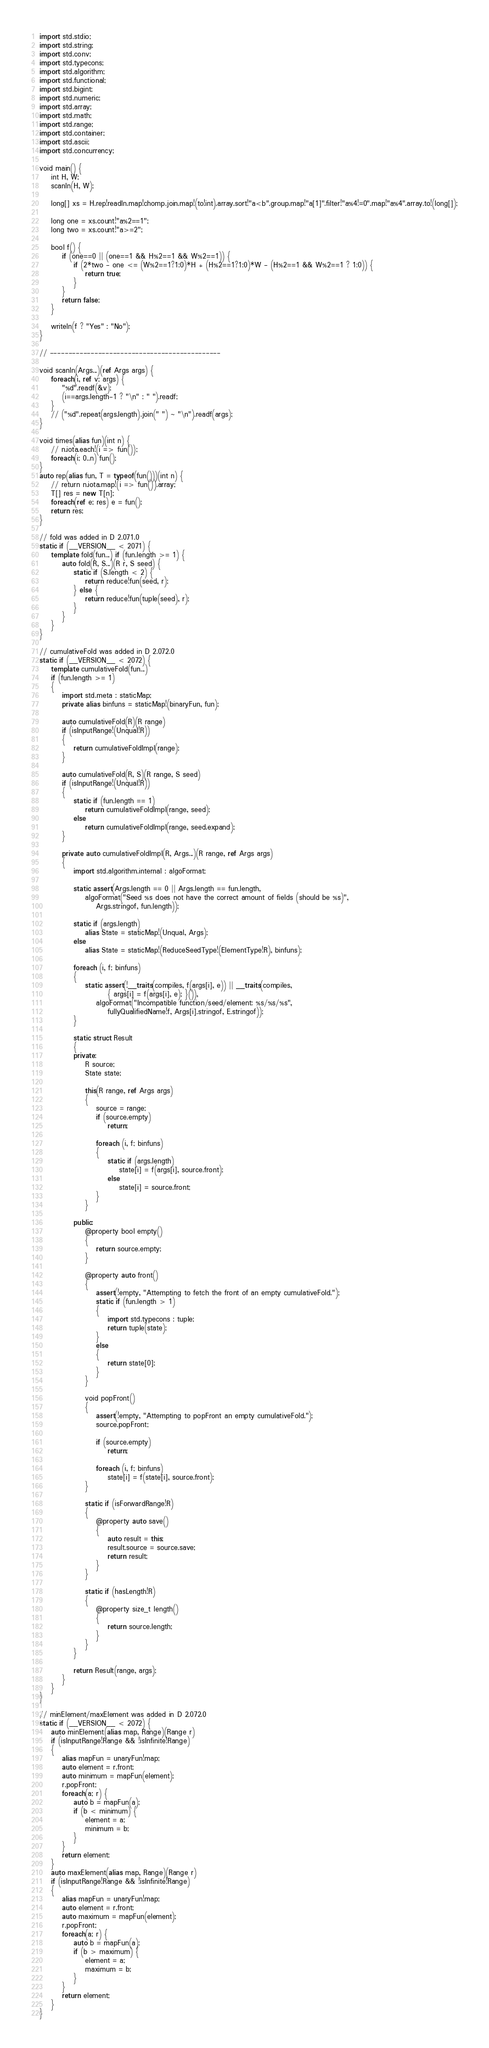Convert code to text. <code><loc_0><loc_0><loc_500><loc_500><_D_>import std.stdio;
import std.string;
import std.conv;
import std.typecons;
import std.algorithm;
import std.functional;
import std.bigint;
import std.numeric;
import std.array;
import std.math;
import std.range;
import std.container;
import std.ascii;
import std.concurrency;

void main() {
    int H, W;
    scanln(H, W);

    long[] xs = H.rep!readln.map!chomp.join.map!(to!int).array.sort!"a<b".group.map!"a[1]".filter!"a%4!=0".map!"a%4".array.to!(long[]);

    long one = xs.count!"a%2==1";
    long two = xs.count!"a>=2";

    bool f() {
        if (one==0 || (one==1 && H%2==1 && W%2==1)) {
            if (2*two - one <= (W%2==1?1:0)*H + (H%2==1?1:0)*W - (H%2==1 && W%2==1 ? 1:0)) {
                return true;
            }
        }
        return false;
    }

    writeln(f ? "Yes" : "No");
}

// ----------------------------------------------

void scanln(Args...)(ref Args args) {
    foreach(i, ref v; args) {
        "%d".readf(&v);
        (i==args.length-1 ? "\n" : " ").readf;
    }
    // ("%d".repeat(args.length).join(" ") ~ "\n").readf(args);
}

void times(alias fun)(int n) {
    // n.iota.each!(i => fun());
    foreach(i; 0..n) fun();
}
auto rep(alias fun, T = typeof(fun()))(int n) {
    // return n.iota.map!(i => fun()).array;
    T[] res = new T[n];
    foreach(ref e; res) e = fun();
    return res;
}

// fold was added in D 2.071.0
static if (__VERSION__ < 2071) {
    template fold(fun...) if (fun.length >= 1) {
        auto fold(R, S...)(R r, S seed) {
            static if (S.length < 2) {
                return reduce!fun(seed, r);
            } else {
                return reduce!fun(tuple(seed), r);
            }
        }
    }
}

// cumulativeFold was added in D 2.072.0
static if (__VERSION__ < 2072) {
    template cumulativeFold(fun...)
    if (fun.length >= 1)
    {
        import std.meta : staticMap;
        private alias binfuns = staticMap!(binaryFun, fun);

        auto cumulativeFold(R)(R range)
        if (isInputRange!(Unqual!R))
        {
            return cumulativeFoldImpl(range);
        }

        auto cumulativeFold(R, S)(R range, S seed)
        if (isInputRange!(Unqual!R))
        {
            static if (fun.length == 1)
                return cumulativeFoldImpl(range, seed);
            else
                return cumulativeFoldImpl(range, seed.expand);
        }

        private auto cumulativeFoldImpl(R, Args...)(R range, ref Args args)
        {
            import std.algorithm.internal : algoFormat;

            static assert(Args.length == 0 || Args.length == fun.length,
                algoFormat("Seed %s does not have the correct amount of fields (should be %s)",
                    Args.stringof, fun.length));

            static if (args.length)
                alias State = staticMap!(Unqual, Args);
            else
                alias State = staticMap!(ReduceSeedType!(ElementType!R), binfuns);

            foreach (i, f; binfuns)
            {
                static assert(!__traits(compiles, f(args[i], e)) || __traits(compiles,
                        { args[i] = f(args[i], e); }()),
                    algoFormat("Incompatible function/seed/element: %s/%s/%s",
                        fullyQualifiedName!f, Args[i].stringof, E.stringof));
            }

            static struct Result
            {
            private:
                R source;
                State state;

                this(R range, ref Args args)
                {
                    source = range;
                    if (source.empty)
                        return;

                    foreach (i, f; binfuns)
                    {
                        static if (args.length)
                            state[i] = f(args[i], source.front);
                        else
                            state[i] = source.front;
                    }
                }

            public:
                @property bool empty()
                {
                    return source.empty;
                }

                @property auto front()
                {
                    assert(!empty, "Attempting to fetch the front of an empty cumulativeFold.");
                    static if (fun.length > 1)
                    {
                        import std.typecons : tuple;
                        return tuple(state);
                    }
                    else
                    {
                        return state[0];
                    }
                }

                void popFront()
                {
                    assert(!empty, "Attempting to popFront an empty cumulativeFold.");
                    source.popFront;

                    if (source.empty)
                        return;

                    foreach (i, f; binfuns)
                        state[i] = f(state[i], source.front);
                }

                static if (isForwardRange!R)
                {
                    @property auto save()
                    {
                        auto result = this;
                        result.source = source.save;
                        return result;
                    }
                }

                static if (hasLength!R)
                {
                    @property size_t length()
                    {
                        return source.length;
                    }
                }
            }

            return Result(range, args);
        }
    }
}

// minElement/maxElement was added in D 2.072.0
static if (__VERSION__ < 2072) {
    auto minElement(alias map, Range)(Range r)
    if (isInputRange!Range && !isInfinite!Range)
    {
        alias mapFun = unaryFun!map;
        auto element = r.front;
        auto minimum = mapFun(element);
        r.popFront;
        foreach(a; r) {
            auto b = mapFun(a);
            if (b < minimum) {
                element = a;
                minimum = b;
            }
        }
        return element;
    }
    auto maxElement(alias map, Range)(Range r)
    if (isInputRange!Range && !isInfinite!Range)
    {
        alias mapFun = unaryFun!map;
        auto element = r.front;
        auto maximum = mapFun(element);
        r.popFront;
        foreach(a; r) {
            auto b = mapFun(a);
            if (b > maximum) {
                element = a;
                maximum = b;
            }
        }
        return element;
    }
}
</code> 